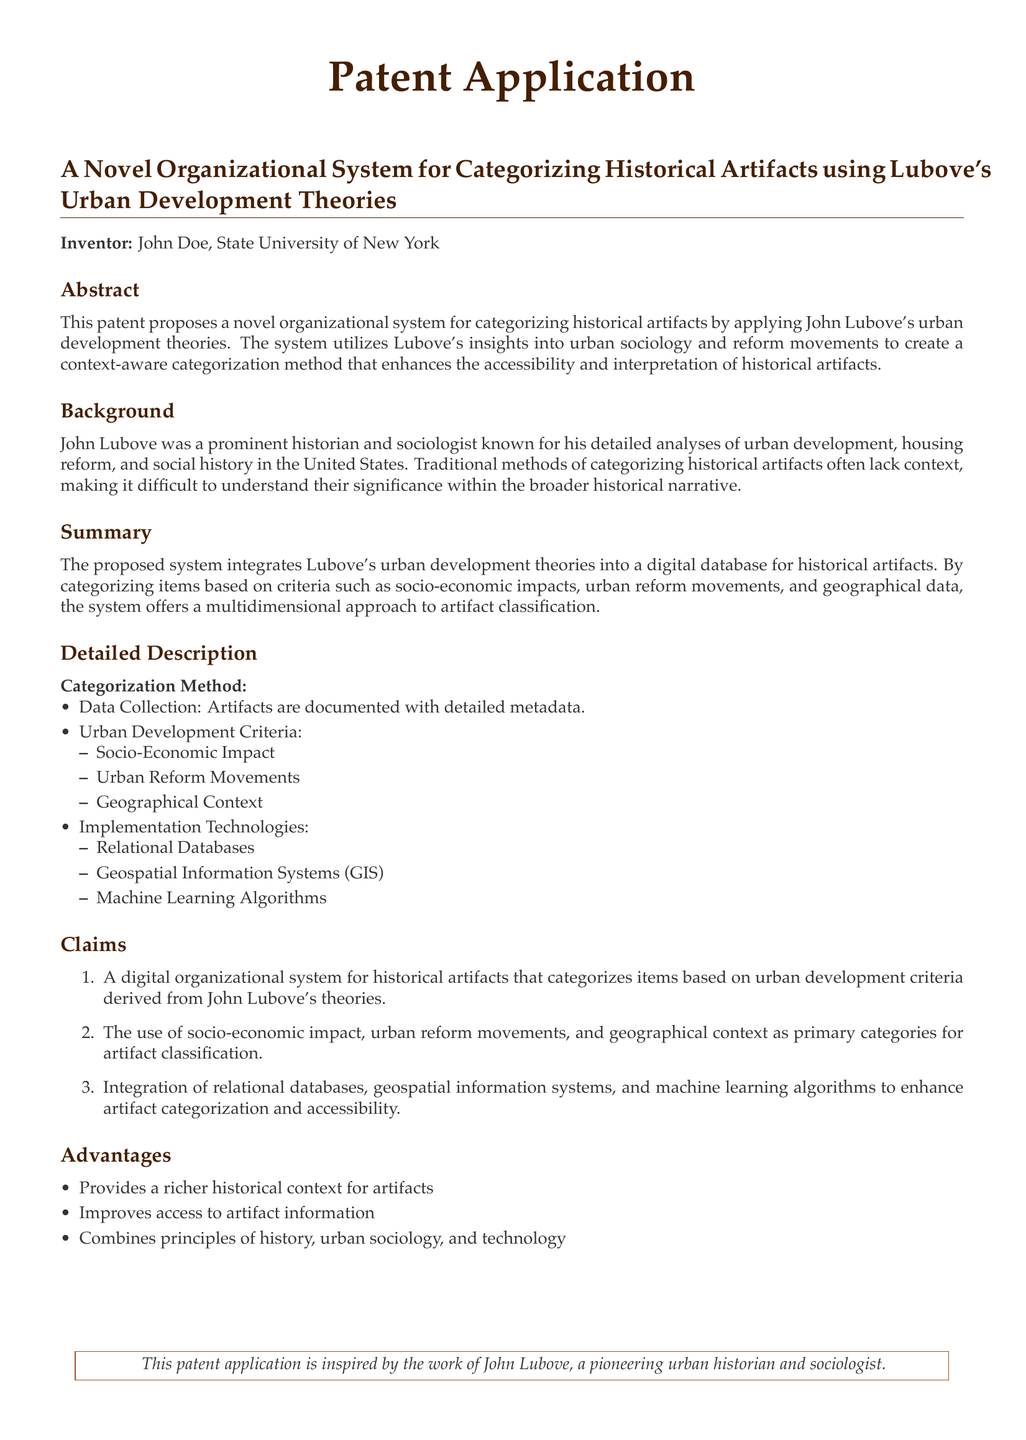What is the title of the patent application? The title is found at the beginning of the document.
Answer: A Novel Organizational System for Categorizing Historical Artifacts using Lubove's Urban Development Theories Who is the inventor of the proposed system? The inventor's name is mentioned in the patent application.
Answer: John Doe What are the primary categories for artifact classification? The document lists these categories under the Claims section.
Answer: Socio-Economic Impact, Urban Reform Movements, Geographical Context What technologies are mentioned for implementation? The implementation technologies are detailed in a list in the Detailed Description section.
Answer: Relational Databases, Geospatial Information Systems (GIS), Machine Learning Algorithms What does the proposed system aim to enhance? The system's aim is summarized in the Abstract section of the document.
Answer: Accessibility and interpretation of historical artifacts What field does John Lubove belong to? Lubove's expertise is introduced in the Background section.
Answer: Historian and sociologist How does the proposed system combine different principles? The advantages section explains this integration succinctly.
Answer: History, urban sociology, and technology 